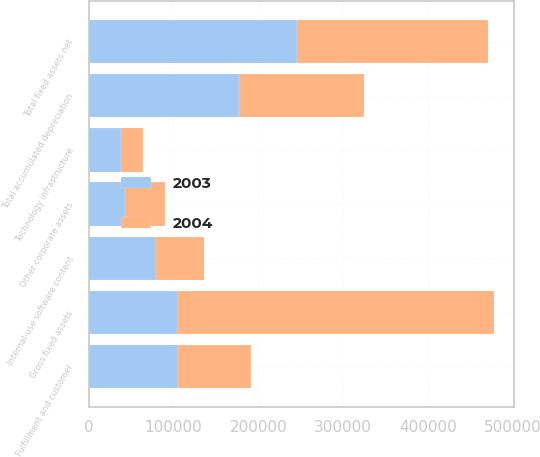Convert chart to OTSL. <chart><loc_0><loc_0><loc_500><loc_500><stacked_bar_chart><ecel><fcel>Fulfillment and customer<fcel>Technology infrastructure<fcel>Internal-use software content<fcel>Other corporate assets<fcel>Gross fixed assets<fcel>Total accumulated depreciation<fcel>Total fixed assets net<nl><fcel>2003<fcel>105939<fcel>38408<fcel>79026<fcel>42527<fcel>105939<fcel>176807<fcel>246156<nl><fcel>2004<fcel>84987<fcel>25592<fcel>57413<fcel>47236<fcel>371738<fcel>147453<fcel>224285<nl></chart> 